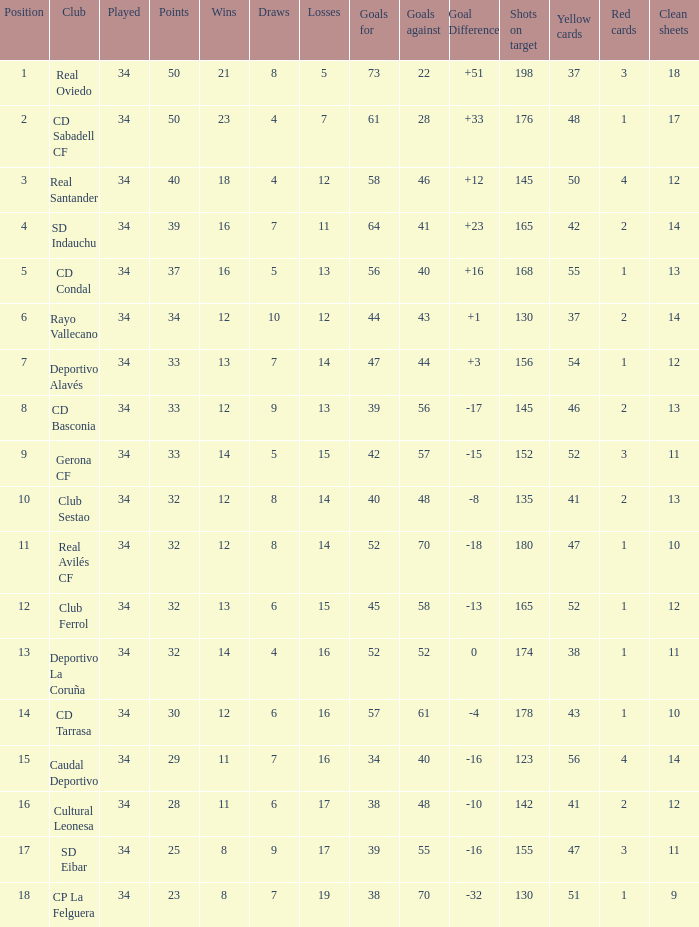Which Losses have a Goal Difference of -16, and less than 8 wins? None. 